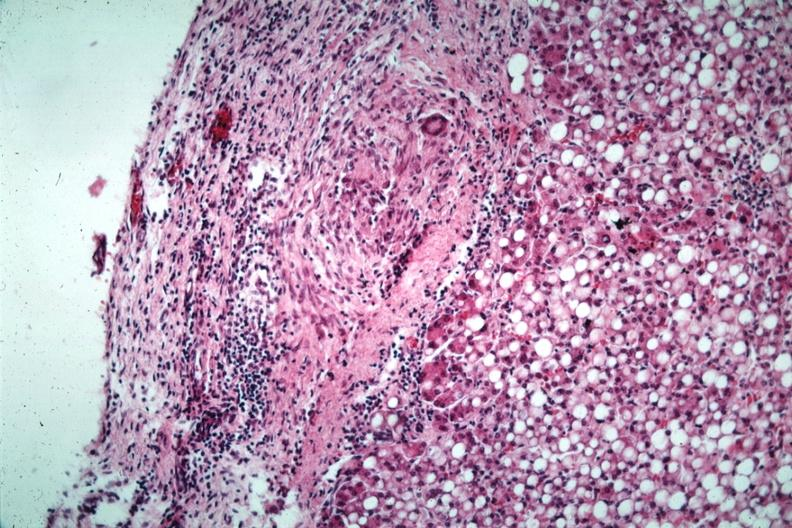s abdomen present?
Answer the question using a single word or phrase. Yes 